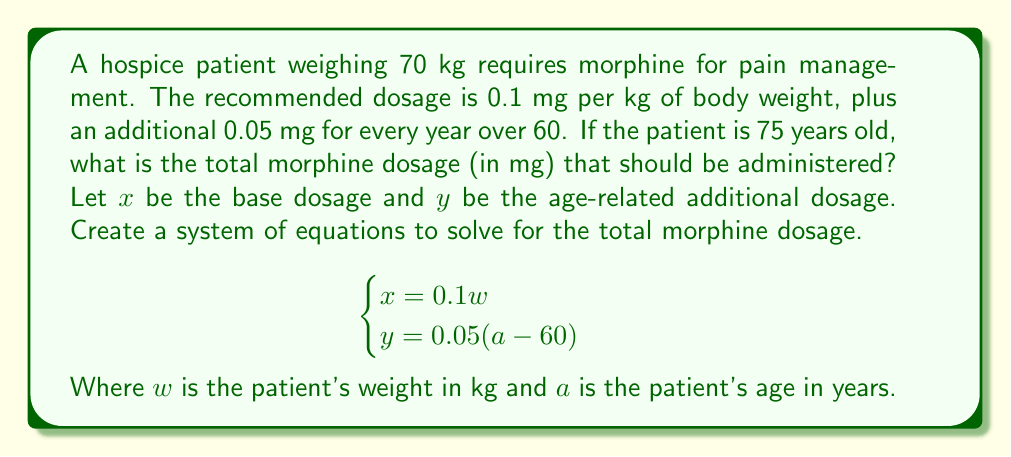What is the answer to this math problem? To solve this problem, we'll use the given system of equations and follow these steps:

1. Calculate the base dosage ($x$):
   $$x = 0.1w = 0.1 \times 70 = 7 \text{ mg}$$

2. Calculate the age-related additional dosage ($y$):
   $$y = 0.05(a - 60) = 0.05(75 - 60) = 0.05 \times 15 = 0.75 \text{ mg}$$

3. Sum the two dosages to get the total morphine dosage:
   $$\text{Total dosage} = x + y = 7 + 0.75 = 7.75 \text{ mg}$$

This calculation ensures that the patient receives the appropriate dosage based on both their weight and age, which is crucial in hospice care for effective pain management while minimizing risks.
Answer: The total morphine dosage that should be administered is 7.75 mg. 